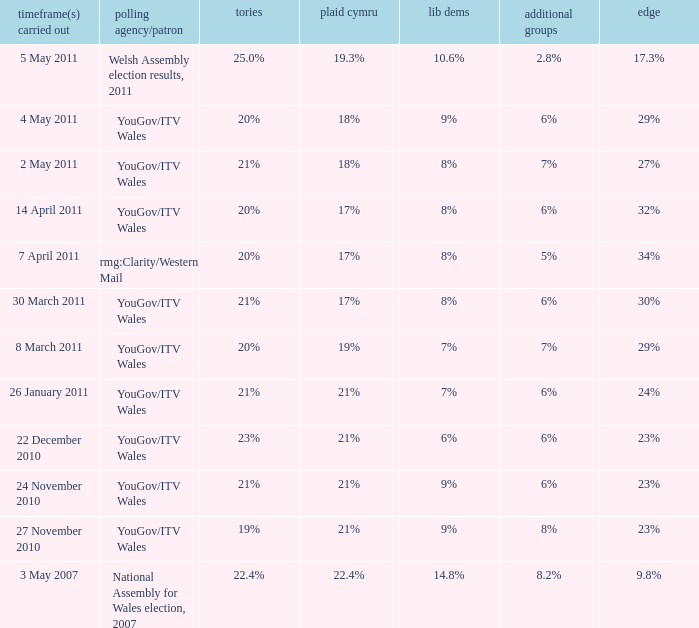Name the others for cons of 21% and lead of 24% 6%. 